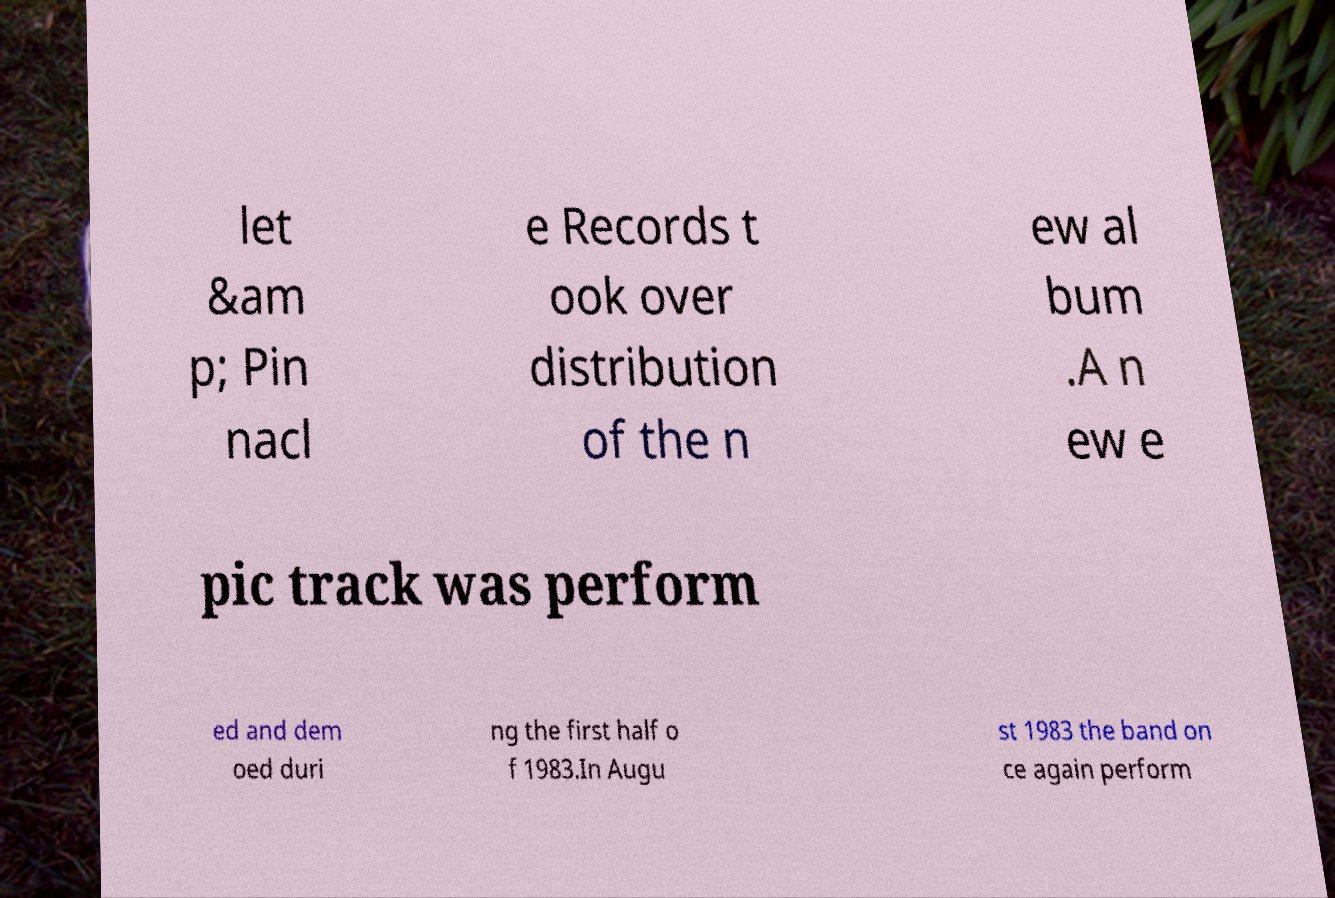There's text embedded in this image that I need extracted. Can you transcribe it verbatim? let &am p; Pin nacl e Records t ook over distribution of the n ew al bum .A n ew e pic track was perform ed and dem oed duri ng the first half o f 1983.In Augu st 1983 the band on ce again perform 